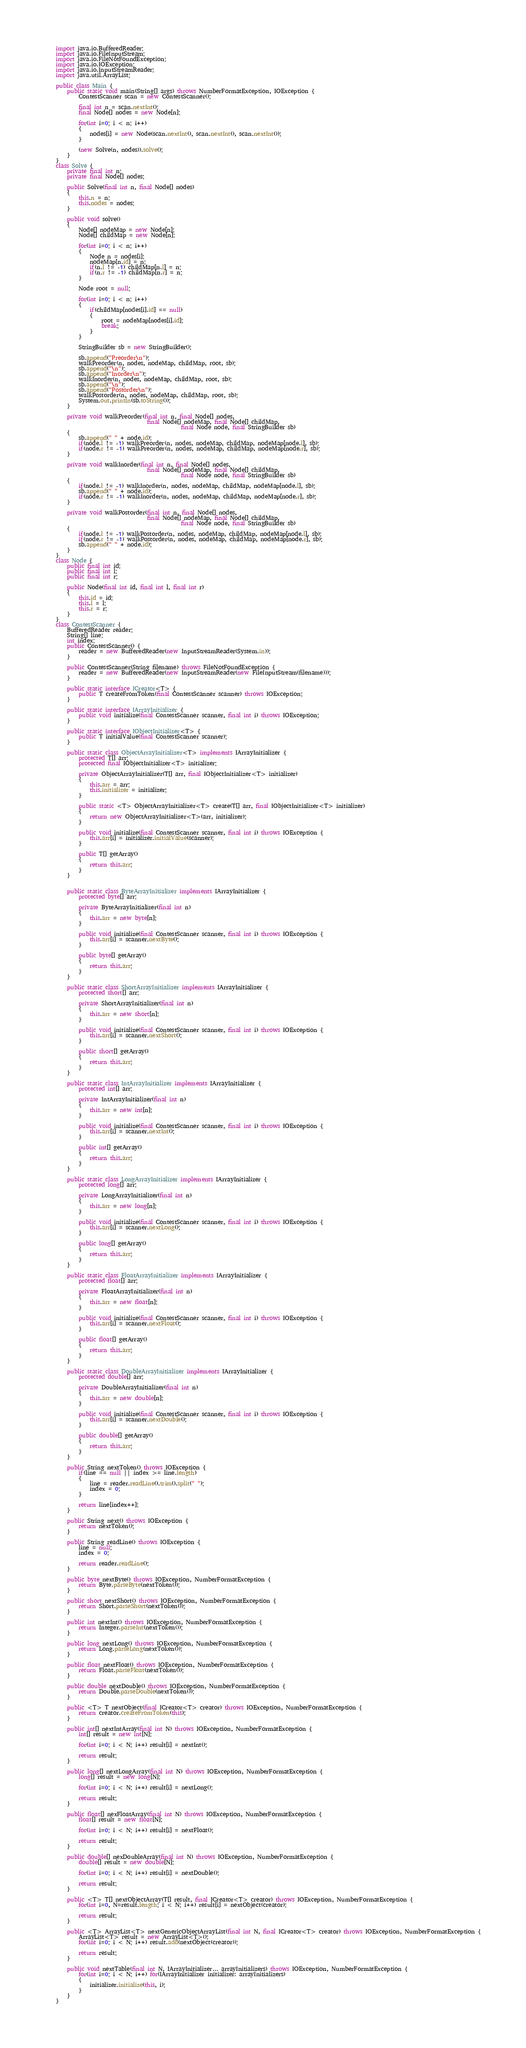<code> <loc_0><loc_0><loc_500><loc_500><_Java_>import java.io.BufferedReader;
import java.io.FileInputStream;
import java.io.FileNotFoundException;
import java.io.IOException;
import java.io.InputStreamReader;
import java.util.ArrayList;

public class Main {
	public static void main(String[] args) throws NumberFormatException, IOException {
		ContestScanner scan = new ContestScanner();

		final int n = scan.nextInt();
		final Node[] nodes = new Node[n];

		for(int i=0; i < n; i++)
		{
			nodes[i] = new Node(scan.nextInt(), scan.nextInt(), scan.nextInt());
		}

		(new Solve(n, nodes)).solve();
	}
}
class Solve {
	private final int n;
	private final Node[] nodes;

	public Solve(final int n, final Node[] nodes)
	{
		this.n = n;
		this.nodes = nodes;
	}

	public void solve()
	{
		Node[] nodeMap = new Node[n];
		Node[] childMap = new Node[n];

		for(int i=0; i < n; i++)
		{
			Node n = nodes[i];
			nodeMap[n.id] = n;
			if(n.l != -1) childMap[n.l] = n;
			if(n.r != -1) childMap[n.r] = n;
		}

		Node root = null;

		for(int i=0; i < n; i++)
		{
			if(childMap[nodes[i].id] == null)
			{
				root = nodeMap[nodes[i].id];
				break;
			}
		}

		StringBuilder sb = new StringBuilder();

		sb.append("Preorder\n");
		walkPreorder(n, nodes, nodeMap, childMap, root, sb);
		sb.append("\n");
		sb.append("Inorder\n");
		walkInorder(n, nodes, nodeMap, childMap, root, sb);
		sb.append("\n");
		sb.append("Postorder\n");
		walkPostorder(n, nodes, nodeMap, childMap, root, sb);
		System.out.println(sb.toString());
	}

	private void walkPreorder(final int n, final Node[] nodes,
								final Node[] nodeMap, final Node[] childMap,
											final Node node, final StringBuilder sb)
	{
		sb.append(" " + node.id);
		if(node.l != -1) walkPreorder(n, nodes, nodeMap, childMap, nodeMap[node.l], sb);
		if(node.r != -1) walkPreorder(n, nodes, nodeMap, childMap, nodeMap[node.r], sb);
	}

	private void walkInorder(final int n, final Node[] nodes,
								final Node[] nodeMap, final Node[] childMap,
											final Node node, final StringBuilder sb)
	{
		if(node.l != -1) walkInorder(n, nodes, nodeMap, childMap, nodeMap[node.l], sb);
		sb.append(" " + node.id);
		if(node.r != -1) walkInorder(n, nodes, nodeMap, childMap, nodeMap[node.r], sb);
	}

	private void walkPostorder(final int n, final Node[] nodes,
								final Node[] nodeMap, final Node[] childMap,
											final Node node, final StringBuilder sb)
	{
		if(node.l != -1) walkPostorder(n, nodes, nodeMap, childMap, nodeMap[node.l], sb);
		if(node.r != -1) walkPostorder(n, nodes, nodeMap, childMap, nodeMap[node.r], sb);
		sb.append(" " + node.id);
	}
}
class Node {
	public final int id;
	public final int l;
	public final int r;

	public Node(final int id, final int l, final int r)
	{
		this.id = id;
		this.l = l;
		this.r = r;
	}
}
class ContestScanner {
	BufferedReader reader;
	String[] line;
	int index;
	public ContestScanner() {
		reader = new BufferedReader(new InputStreamReader(System.in));
	}

	public ContestScanner(String filename) throws FileNotFoundException {
		reader = new BufferedReader(new InputStreamReader(new FileInputStream(filename)));
	}

	public static interface ICreator<T> {
		public T createFromToken(final ContestScanner scanner) throws IOException;
	}

	public static interface IArrayInitializer {
		public void initialize(final ContestScanner scanner, final int i) throws IOException;
	}

	public static interface IObjectInitializer<T> {
		public T initialValue(final ContestScanner scanner);
	}

	public static class ObjectArrayInitializer<T> implements IArrayInitializer {
		protected T[] arr;
		protected final IObjectInitializer<T> initializer;

		private ObjectArrayInitializer(T[] arr, final IObjectInitializer<T> initializer)
		{
			this.arr = arr;
			this.initializer = initializer;
		}

		public static <T> ObjectArrayInitializer<T> create(T[] arr, final IObjectInitializer<T> initializer)
		{
			return new ObjectArrayInitializer<T>(arr, initializer);
		}

		public void initialize(final ContestScanner scanner, final int i) throws IOException {
			this.arr[i] = initializer.initialValue(scanner);
		}

		public T[] getArray()
		{
			return this.arr;
		}
	}


	public static class ByteArrayInitializer implements IArrayInitializer {
		protected byte[] arr;

		private ByteArrayInitializer(final int n)
		{
			this.arr = new byte[n];
		}

		public void initialize(final ContestScanner scanner, final int i) throws IOException {
			this.arr[i] = scanner.nextByte();
		}

		public byte[] getArray()
		{
			return this.arr;
		}
	}

	public static class ShortArrayInitializer implements IArrayInitializer {
		protected short[] arr;

		private ShortArrayInitializer(final int n)
		{
			this.arr = new short[n];
		}

		public void initialize(final ContestScanner scanner, final int i) throws IOException {
			this.arr[i] = scanner.nextShort();
		}

		public short[] getArray()
		{
			return this.arr;
		}
	}

	public static class IntArrayInitializer implements IArrayInitializer {
		protected int[] arr;

		private IntArrayInitializer(final int n)
		{
			this.arr = new int[n];
		}

		public void initialize(final ContestScanner scanner, final int i) throws IOException {
			this.arr[i] = scanner.nextInt();
		}

		public int[] getArray()
		{
			return this.arr;
		}
	}

	public static class LongArrayInitializer implements IArrayInitializer {
		protected long[] arr;

		private LongArrayInitializer(final int n)
		{
			this.arr = new long[n];
		}

		public void initialize(final ContestScanner scanner, final int i) throws IOException {
			this.arr[i] = scanner.nextLong();
		}

		public long[] getArray()
		{
			return this.arr;
		}
	}

	public static class FloatArrayInitializer implements IArrayInitializer {
		protected float[] arr;

		private FloatArrayInitializer(final int n)
		{
			this.arr = new float[n];
		}

		public void initialize(final ContestScanner scanner, final int i) throws IOException {
			this.arr[i] = scanner.nextFloat();
		}

		public float[] getArray()
		{
			return this.arr;
		}
	}

	public static class DoubleArrayInitializer implements IArrayInitializer {
		protected double[] arr;

		private DoubleArrayInitializer(final int n)
		{
			this.arr = new double[n];
		}

		public void initialize(final ContestScanner scanner, final int i) throws IOException {
			this.arr[i] = scanner.nextDouble();
		}

		public double[] getArray()
		{
			return this.arr;
		}
	}

	public String nextToken() throws IOException {
		if(line == null || index >= line.length)
		{
			line = reader.readLine().trim().split(" ");
			index = 0;
		}

		return line[index++];
	}

	public String next() throws IOException {
		return nextToken();
	}

	public String readLine() throws IOException {
		line = null;
		index = 0;

		return reader.readLine();
	}

	public byte nextByte() throws IOException, NumberFormatException {
		return Byte.parseByte(nextToken());
	}

	public short nextShort() throws IOException, NumberFormatException {
		return Short.parseShort(nextToken());
	}

	public int nextInt() throws IOException, NumberFormatException {
		return Integer.parseInt(nextToken());
	}

	public long nextLong() throws IOException, NumberFormatException {
		return Long.parseLong(nextToken());
	}

	public float nextFloat() throws IOException, NumberFormatException {
		return Float.parseFloat(nextToken());
	}

	public double nextDouble() throws IOException, NumberFormatException {
		return Double.parseDouble(nextToken());
	}

	public <T> T nextObject(final ICreator<T> creator) throws IOException, NumberFormatException {
		return creator.createFromToken(this);
	}

	public int[] nextIntArray(final int N) throws IOException, NumberFormatException {
		int[] result = new int[N];

		for(int i=0; i < N; i++) result[i] = nextInt();

		return result;
	}

	public long[] nextLongArray(final int N) throws IOException, NumberFormatException {
		long[] result = new long[N];

		for(int i=0; i < N; i++) result[i] = nextLong();

		return result;
	}

	public float[] nexFloatArray(final int N) throws IOException, NumberFormatException {
		float[] result = new float[N];

		for(int i=0; i < N; i++) result[i] = nextFloat();

		return result;
	}

	public double[] nexDoubleArray(final int N) throws IOException, NumberFormatException {
		double[] result = new double[N];

		for(int i=0; i < N; i++) result[i] = nextDouble();

		return result;
	}

	public <T> T[] nextObjectArray(T[] result, final ICreator<T> creator) throws IOException, NumberFormatException {
		for(int i=0, N=result.length; i < N; i++) result[i] = nextObject(creator);

		return result;
	}

	public <T> ArrayList<T> nextGenericObjectArrayList(final int N, final ICreator<T> creator) throws IOException, NumberFormatException {
		ArrayList<T> result = new ArrayList<T>();
		for(int i=0; i < N; i++) result.add(nextObject(creator));

		return result;
	}

	public void nextTable(final int N, IArrayInitializer... arrayInitializers) throws IOException, NumberFormatException {
		for(int i=0; i < N; i++) for(IArrayInitializer initializer: arrayInitializers)
		{
			initializer.initialize(this, i);
		}
	}
}</code> 